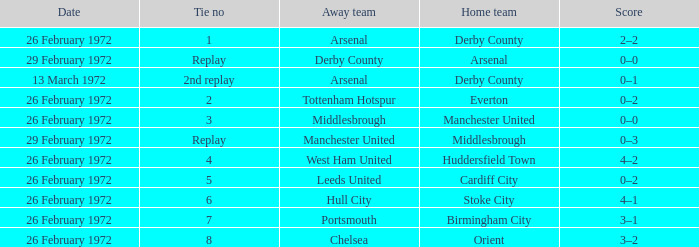Which Tie is from birmingham city? 7.0. 